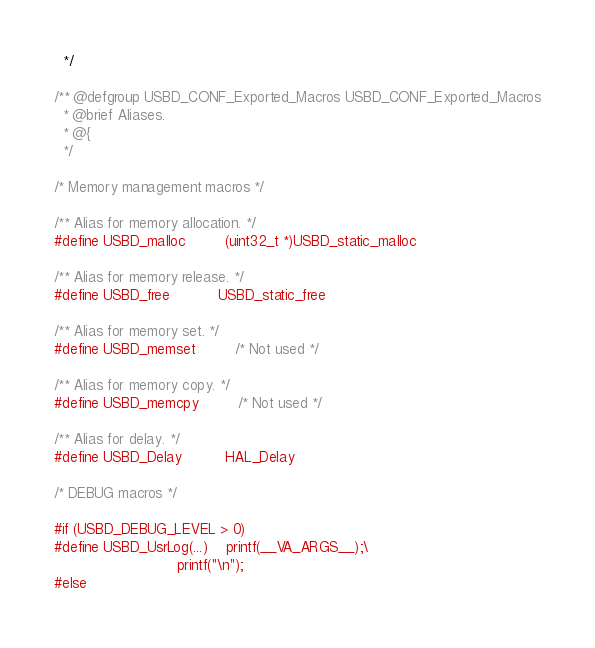Convert code to text. <code><loc_0><loc_0><loc_500><loc_500><_C_>  */

/** @defgroup USBD_CONF_Exported_Macros USBD_CONF_Exported_Macros
  * @brief Aliases.
  * @{
  */

/* Memory management macros */

/** Alias for memory allocation. */
#define USBD_malloc         (uint32_t *)USBD_static_malloc

/** Alias for memory release. */
#define USBD_free           USBD_static_free

/** Alias for memory set. */
#define USBD_memset         /* Not used */

/** Alias for memory copy. */
#define USBD_memcpy         /* Not used */

/** Alias for delay. */
#define USBD_Delay          HAL_Delay

/* DEBUG macros */

#if (USBD_DEBUG_LEVEL > 0)
#define USBD_UsrLog(...)    printf(__VA_ARGS__);\
                            printf("\n");
#else</code> 